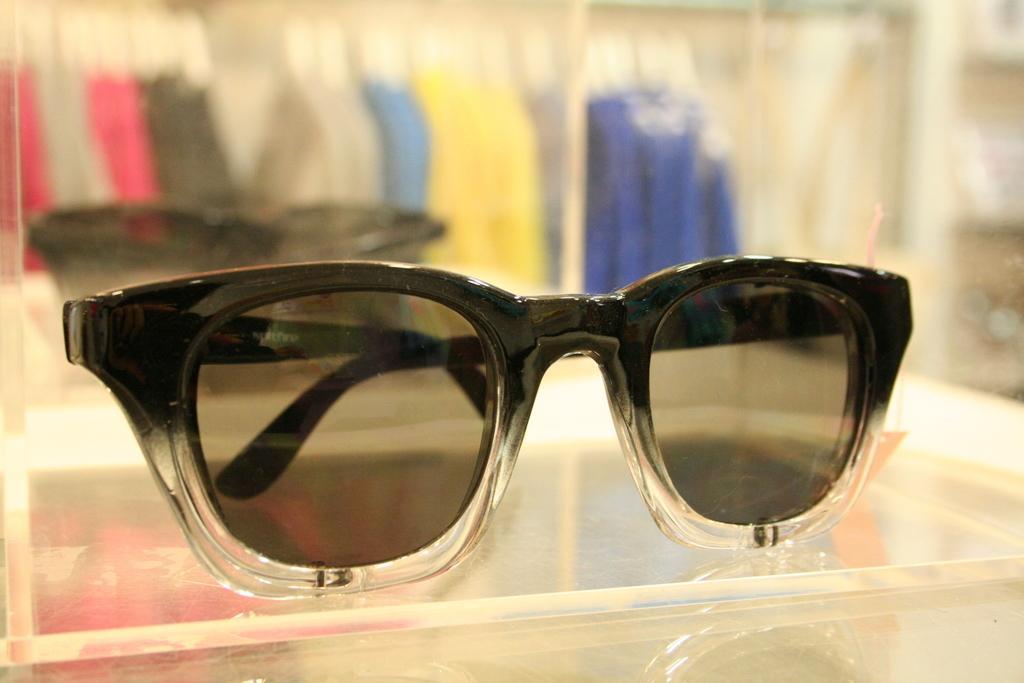Can you describe this image briefly? In the image there are goggles in the foreground and the background of the goggles is blur. 